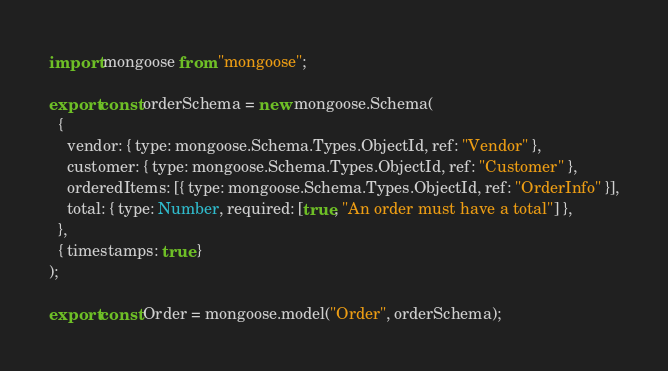<code> <loc_0><loc_0><loc_500><loc_500><_JavaScript_>import mongoose from "mongoose";

export const orderSchema = new mongoose.Schema(
  {
    vendor: { type: mongoose.Schema.Types.ObjectId, ref: "Vendor" },
    customer: { type: mongoose.Schema.Types.ObjectId, ref: "Customer" },
    orderedItems: [{ type: mongoose.Schema.Types.ObjectId, ref: "OrderInfo" }],
    total: { type: Number, required: [true, "An order must have a total"] },
  },
  { timestamps: true }
);

export const Order = mongoose.model("Order", orderSchema);
</code> 